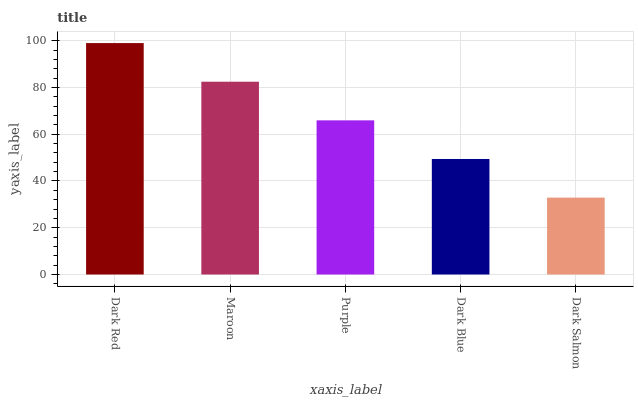Is Dark Salmon the minimum?
Answer yes or no. Yes. Is Dark Red the maximum?
Answer yes or no. Yes. Is Maroon the minimum?
Answer yes or no. No. Is Maroon the maximum?
Answer yes or no. No. Is Dark Red greater than Maroon?
Answer yes or no. Yes. Is Maroon less than Dark Red?
Answer yes or no. Yes. Is Maroon greater than Dark Red?
Answer yes or no. No. Is Dark Red less than Maroon?
Answer yes or no. No. Is Purple the high median?
Answer yes or no. Yes. Is Purple the low median?
Answer yes or no. Yes. Is Maroon the high median?
Answer yes or no. No. Is Dark Blue the low median?
Answer yes or no. No. 